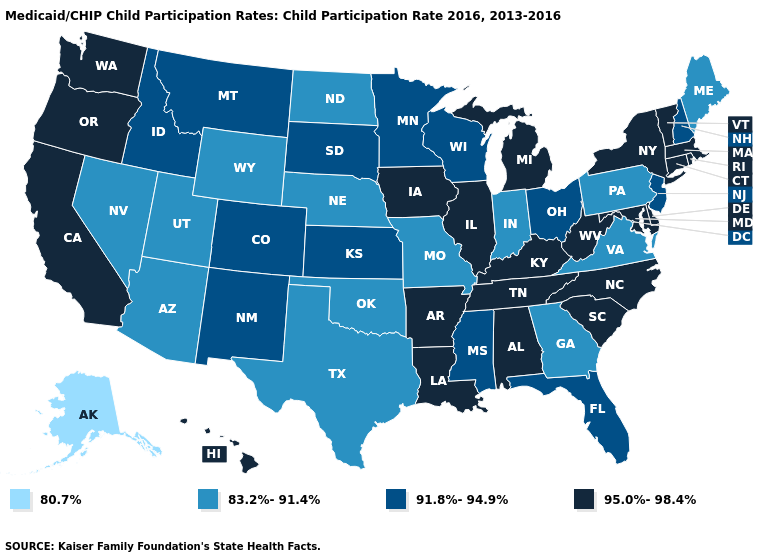What is the lowest value in states that border North Carolina?
Be succinct. 83.2%-91.4%. Does New York have the lowest value in the Northeast?
Answer briefly. No. Does New Mexico have a lower value than Pennsylvania?
Quick response, please. No. Does Missouri have a higher value than Alaska?
Quick response, please. Yes. What is the value of Utah?
Write a very short answer. 83.2%-91.4%. What is the lowest value in states that border Georgia?
Short answer required. 91.8%-94.9%. Among the states that border South Carolina , which have the lowest value?
Answer briefly. Georgia. What is the lowest value in states that border Delaware?
Concise answer only. 83.2%-91.4%. Among the states that border Georgia , which have the lowest value?
Quick response, please. Florida. Which states hav the highest value in the MidWest?
Be succinct. Illinois, Iowa, Michigan. Name the states that have a value in the range 95.0%-98.4%?
Write a very short answer. Alabama, Arkansas, California, Connecticut, Delaware, Hawaii, Illinois, Iowa, Kentucky, Louisiana, Maryland, Massachusetts, Michigan, New York, North Carolina, Oregon, Rhode Island, South Carolina, Tennessee, Vermont, Washington, West Virginia. What is the lowest value in the MidWest?
Write a very short answer. 83.2%-91.4%. What is the value of Missouri?
Keep it brief. 83.2%-91.4%. What is the value of Indiana?
Concise answer only. 83.2%-91.4%. Among the states that border Georgia , does Florida have the lowest value?
Give a very brief answer. Yes. 